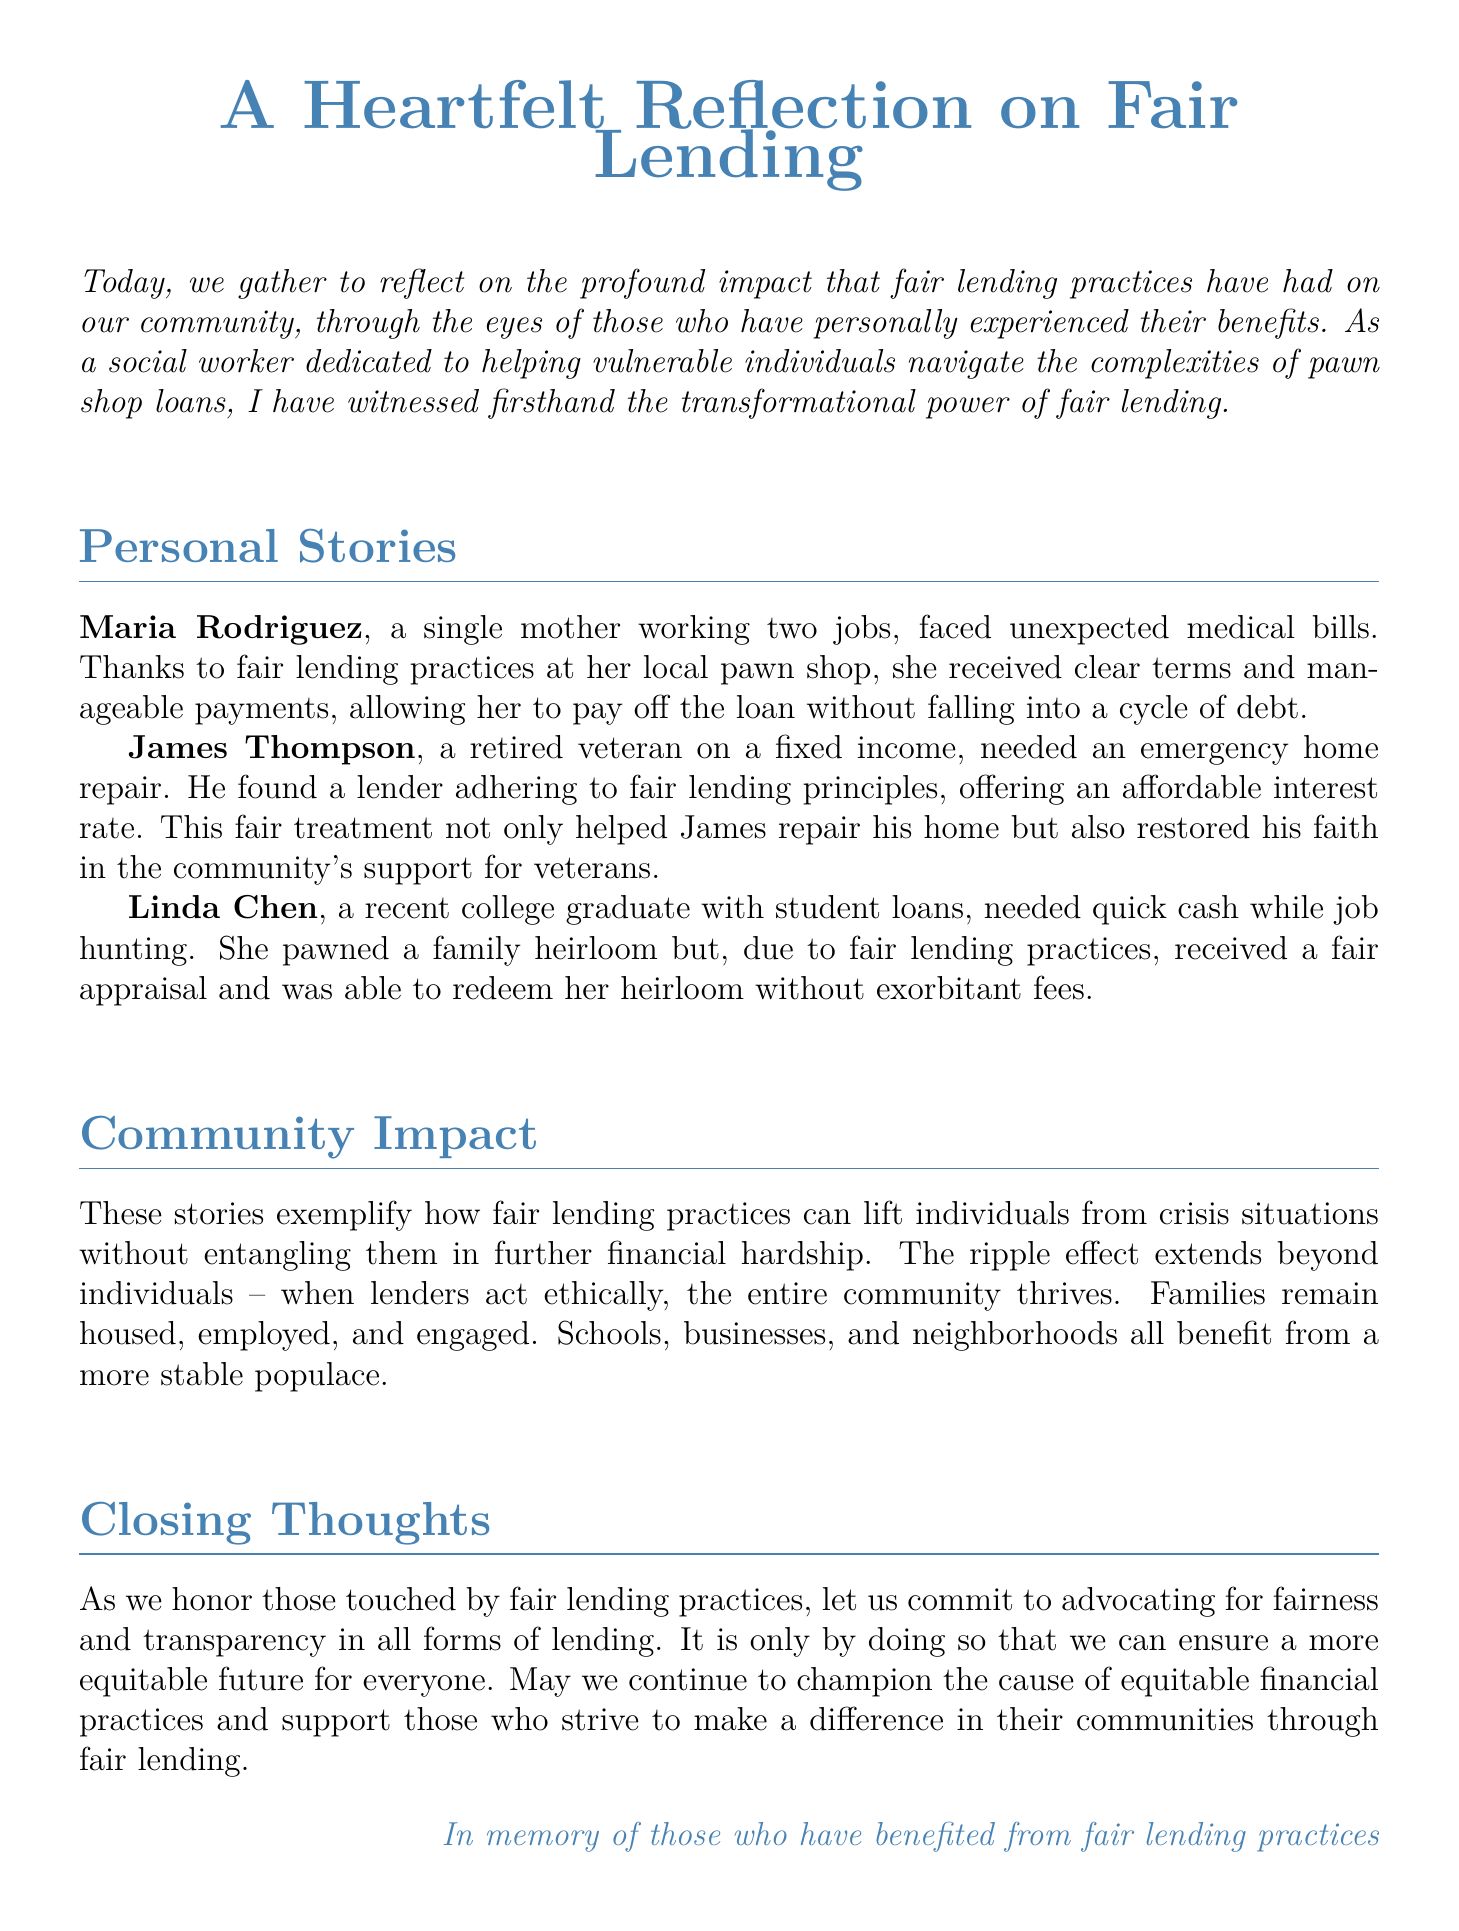What is the main theme of the document? The document reflects on the impact of fair lending practices on individuals and the community.
Answer: Fair lending practices Who is Maria Rodriguez? She is a single mother who benefited from fair lending practices to manage medical bills.
Answer: A single mother What type of repairs did James Thompson need? He needed an emergency home repair that was facilitated through fair lending.
Answer: Home repair What was Linda Chen's financial situation? She was a recent college graduate needing quick cash while job hunting.
Answer: Recent college graduate What is emphasized as beneficial for the whole community? Ethical lending practices lead to stability and support for families.
Answer: Ethical lending practices In memory of whom is the document dedicated? The document is dedicated to those who have benefited from fair lending practices.
Answer: Those who have benefited from fair lending practices 